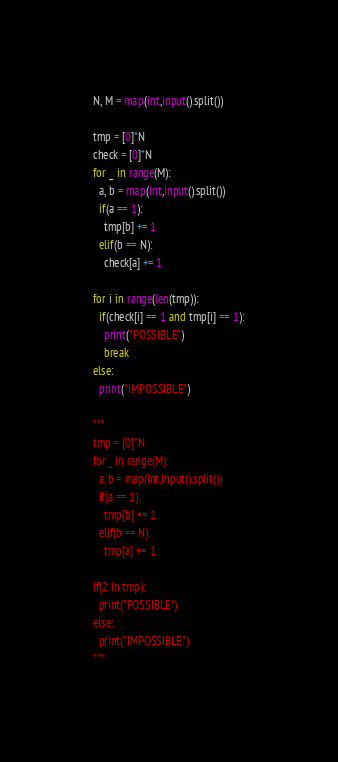Convert code to text. <code><loc_0><loc_0><loc_500><loc_500><_Python_>N, M = map(int,input().split())

tmp = [0]*N
check = [0]*N
for _ in range(M):
  a, b = map(int,input().split())
  if(a == 1):
    tmp[b] += 1
  elif(b == N):
    check[a] += 1

for i in range(len(tmp)):
  if(check[i] == 1 and tmp[i] == 1):
    print("POSSIBLE")
    break
else:
  print("IMPOSSIBLE")

"""
tmp = [0]*N
for _ in range(M):
  a, b = map(int,input().split())
  if(a == 1):
    tmp[b] += 1
  elif(b == N):
    tmp[a] += 1

if(2 in tmp):
  print("POSSIBLE")
else:
  print("IMPOSSIBLE")
"""</code> 